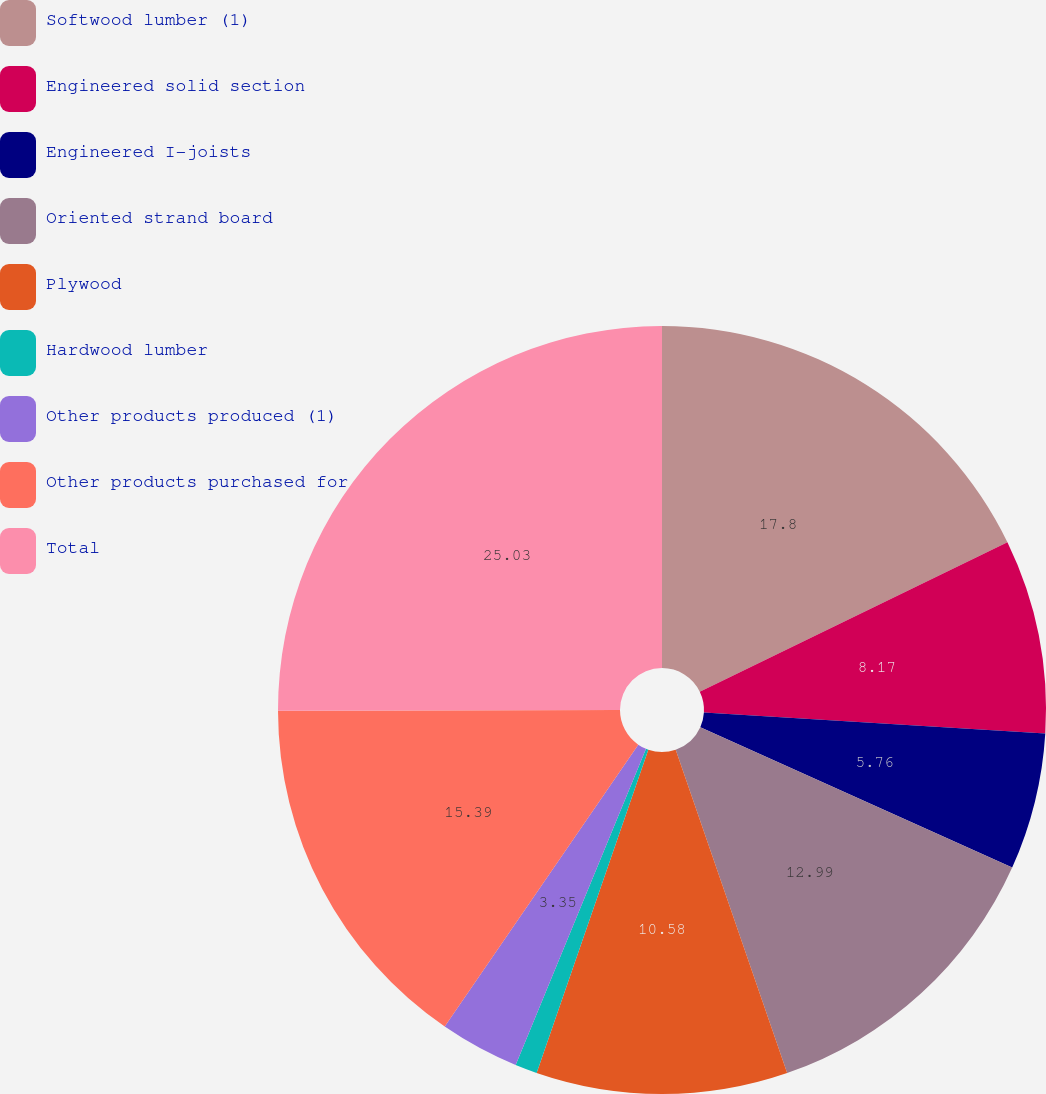<chart> <loc_0><loc_0><loc_500><loc_500><pie_chart><fcel>Softwood lumber (1)<fcel>Engineered solid section<fcel>Engineered I-joists<fcel>Oriented strand board<fcel>Plywood<fcel>Hardwood lumber<fcel>Other products produced (1)<fcel>Other products purchased for<fcel>Total<nl><fcel>17.81%<fcel>8.17%<fcel>5.76%<fcel>12.99%<fcel>10.58%<fcel>0.93%<fcel>3.35%<fcel>15.4%<fcel>25.04%<nl></chart> 